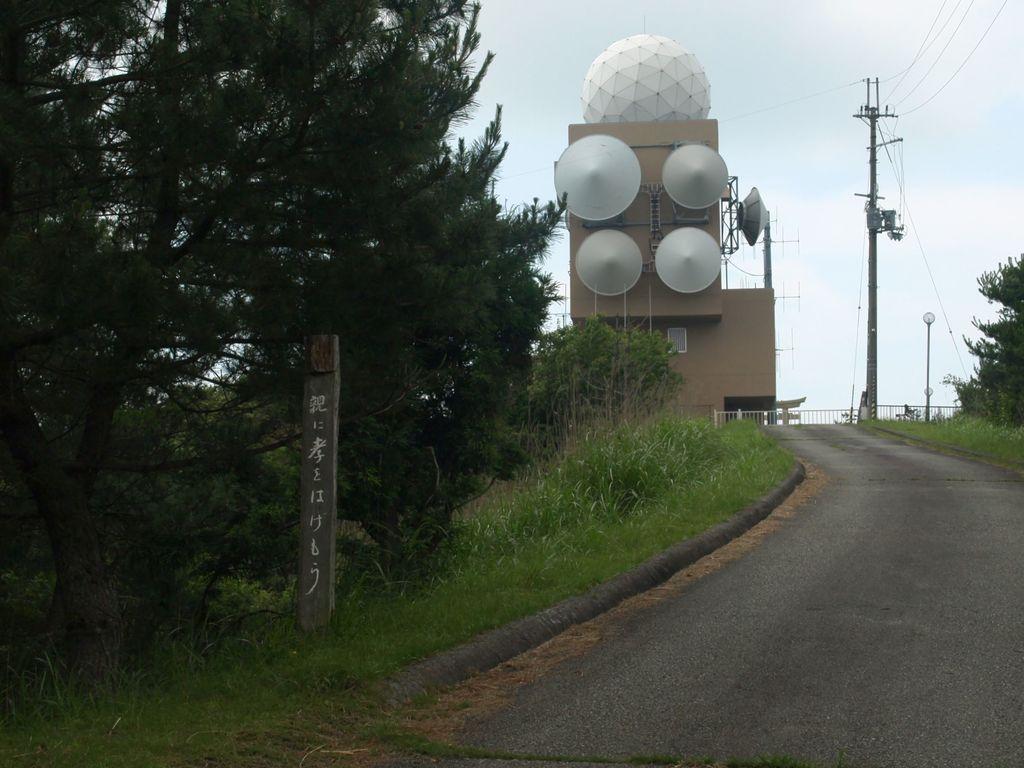In one or two sentences, can you explain what this image depicts? In the background of the image there is a building. There is a electric pole and wires. To the left side of the image there are trees,grass. In the center of the image there is road. 